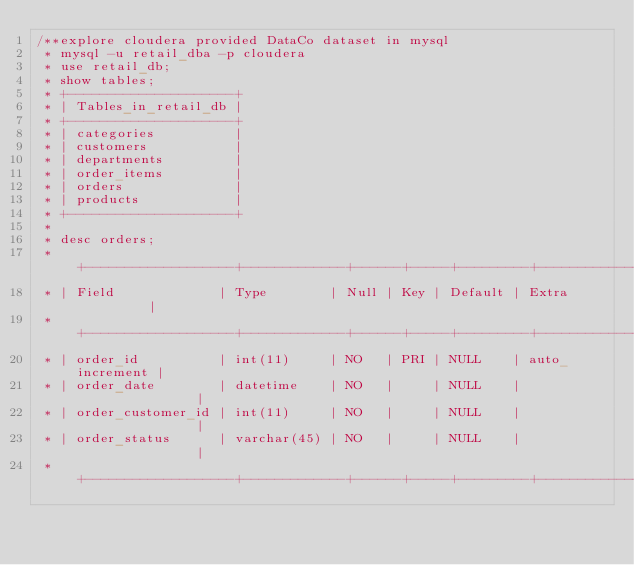<code> <loc_0><loc_0><loc_500><loc_500><_Scala_>/**explore cloudera provided DataCo dataset in mysql
 * mysql -u retail_dba -p cloudera
 * use retail_db;
 * show tables;
 * +---------------------+
 * | Tables_in_retail_db |
 * +---------------------+
 * | categories          |
 * | customers           |
 * | departments         |
 * | order_items         |
 * | orders              |
 * | products            |
 * +---------------------+
 * 
 * desc orders;
 * +-------------------+-------------+------+-----+---------+----------------+
 * | Field             | Type        | Null | Key | Default | Extra          |
 * +-------------------+-------------+------+-----+---------+----------------+
 * | order_id          | int(11)     | NO   | PRI | NULL    | auto_increment |
 * | order_date        | datetime    | NO   |     | NULL    |                |
 * | order_customer_id | int(11)     | NO   |     | NULL    |                |
 * | order_status      | varchar(45) | NO   |     | NULL    |                |
 * +-------------------+-------------+------+-----+---------+----------------+</code> 